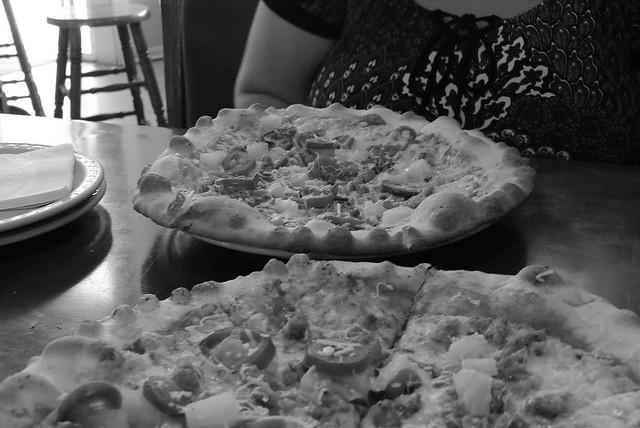Is this food sweet?
Write a very short answer. No. What is on the plates?
Write a very short answer. Pizza. How many people do you see?
Answer briefly. 1. How many legs does the stool have?
Short answer required. 4. What number is on this cake?
Short answer required. 0. 